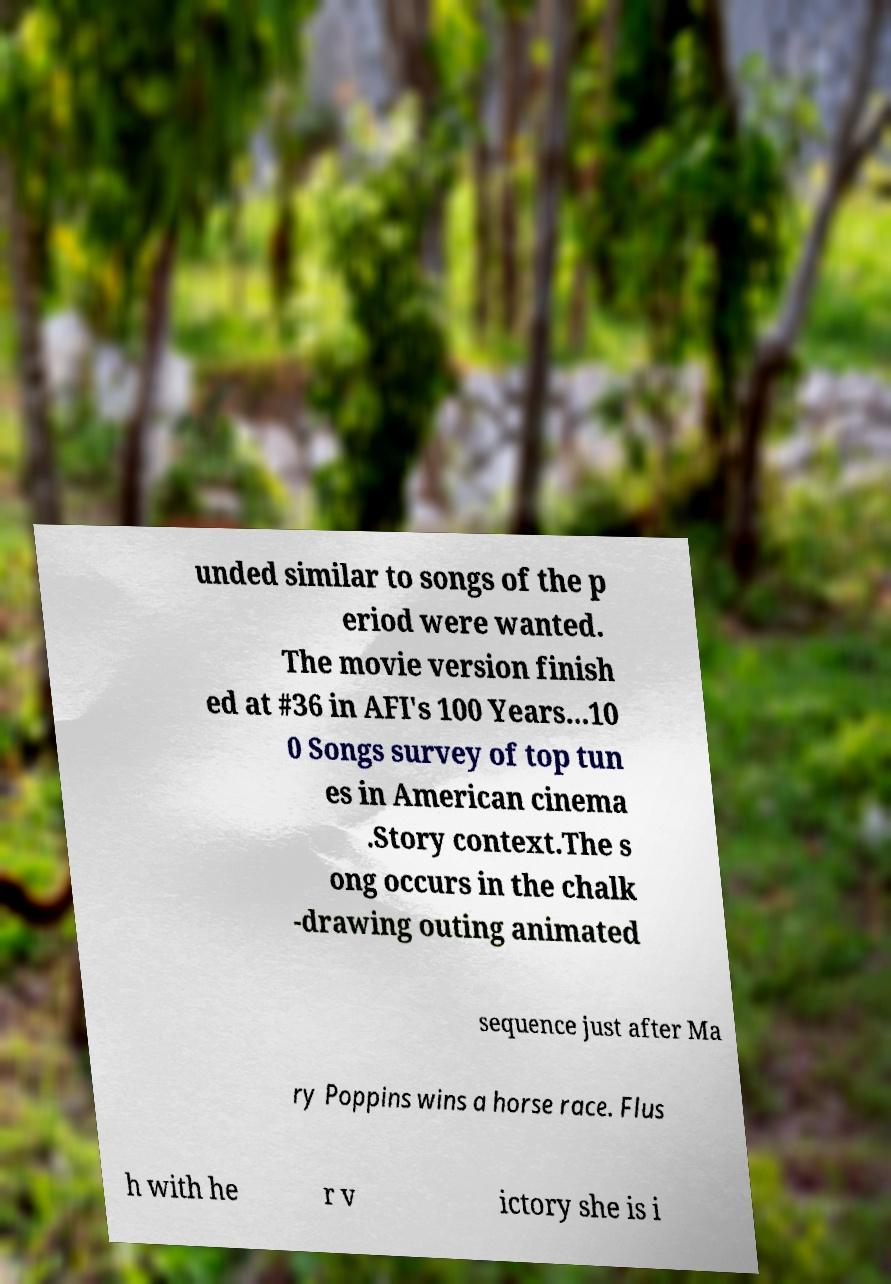Please read and relay the text visible in this image. What does it say? unded similar to songs of the p eriod were wanted. The movie version finish ed at #36 in AFI's 100 Years...10 0 Songs survey of top tun es in American cinema .Story context.The s ong occurs in the chalk -drawing outing animated sequence just after Ma ry Poppins wins a horse race. Flus h with he r v ictory she is i 